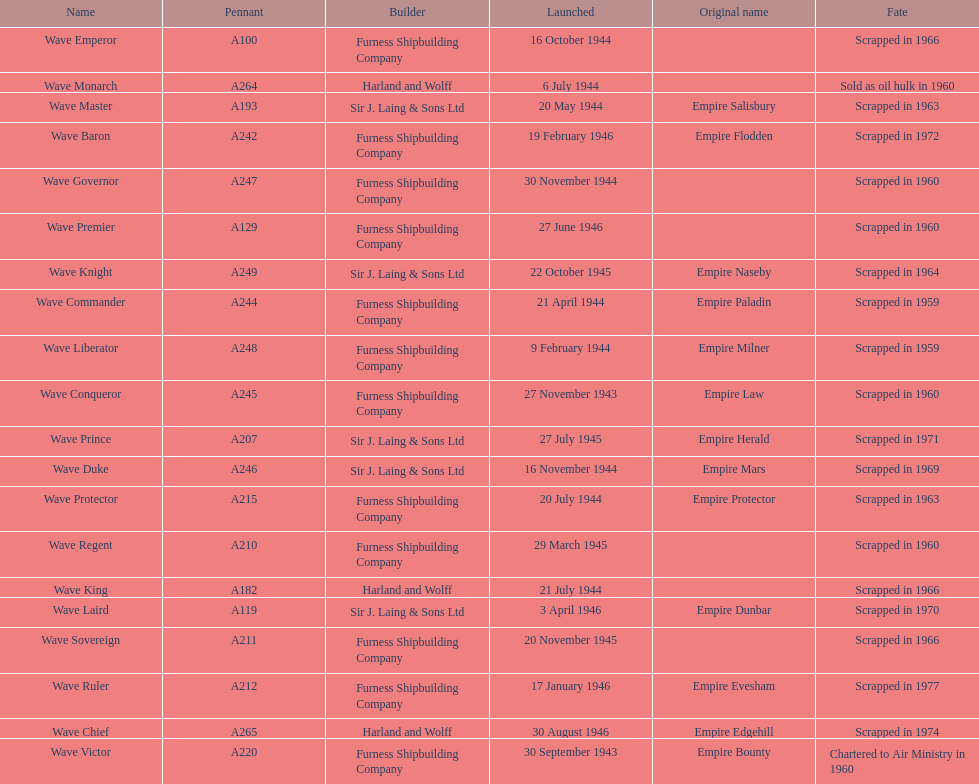Which other ship was launched in the same year as the wave victor? Wave Conqueror. 